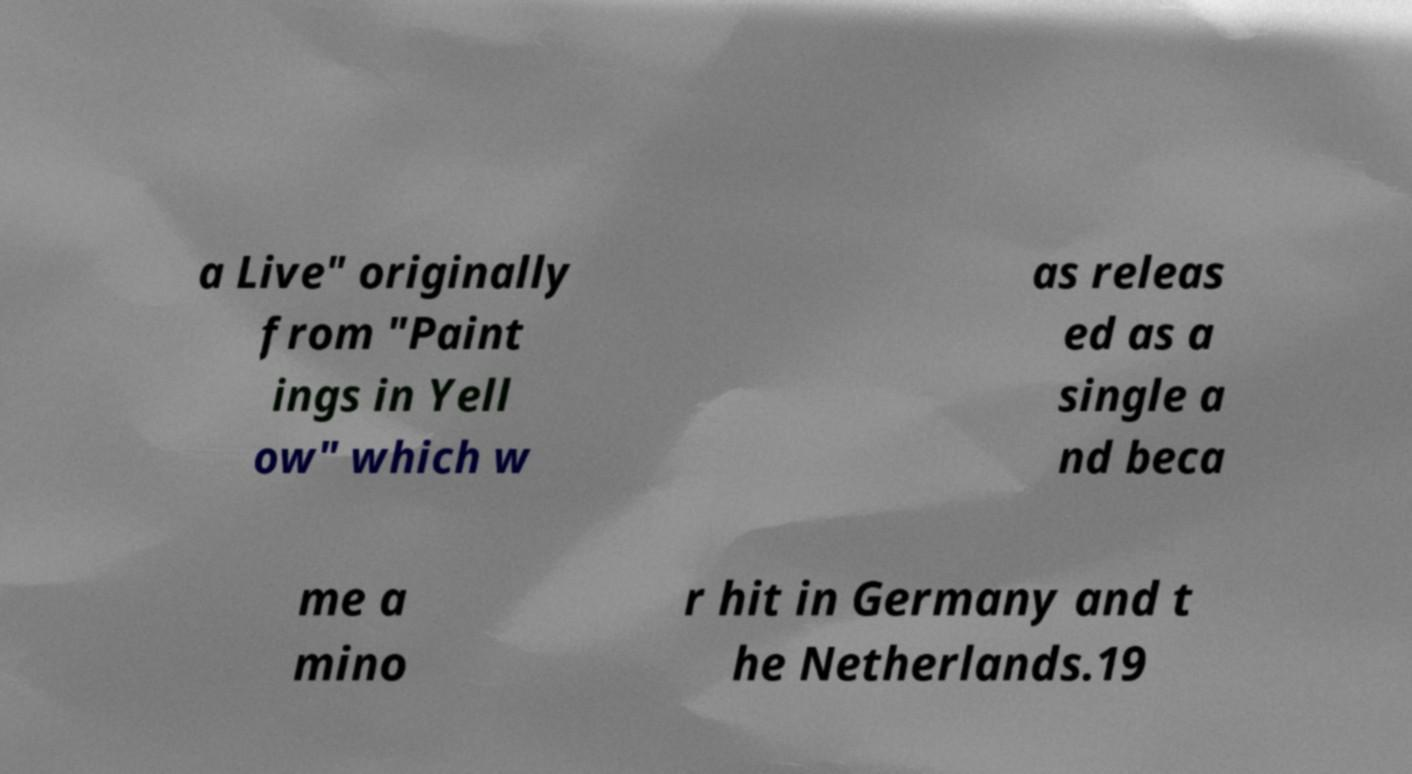Please read and relay the text visible in this image. What does it say? a Live" originally from "Paint ings in Yell ow" which w as releas ed as a single a nd beca me a mino r hit in Germany and t he Netherlands.19 